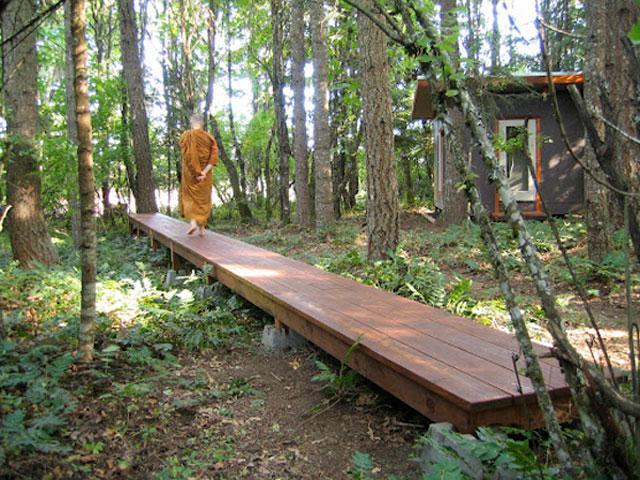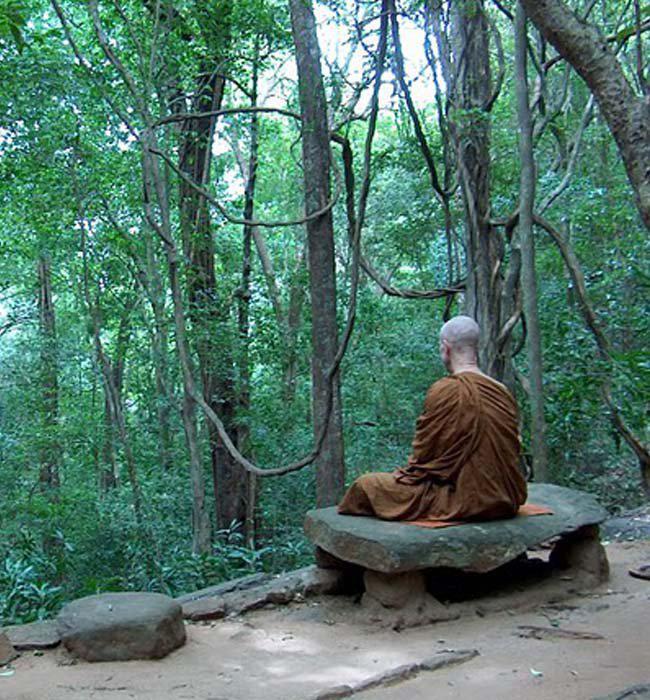The first image is the image on the left, the second image is the image on the right. Examine the images to the left and right. Is the description "In the right image, a figure is sitting in a lotus position on an elevated platform surrounded by foliage and curving vines." accurate? Answer yes or no. Yes. The first image is the image on the left, the second image is the image on the right. Analyze the images presented: Is the assertion "In at least one image there is a single monk walking away into a forest." valid? Answer yes or no. Yes. 